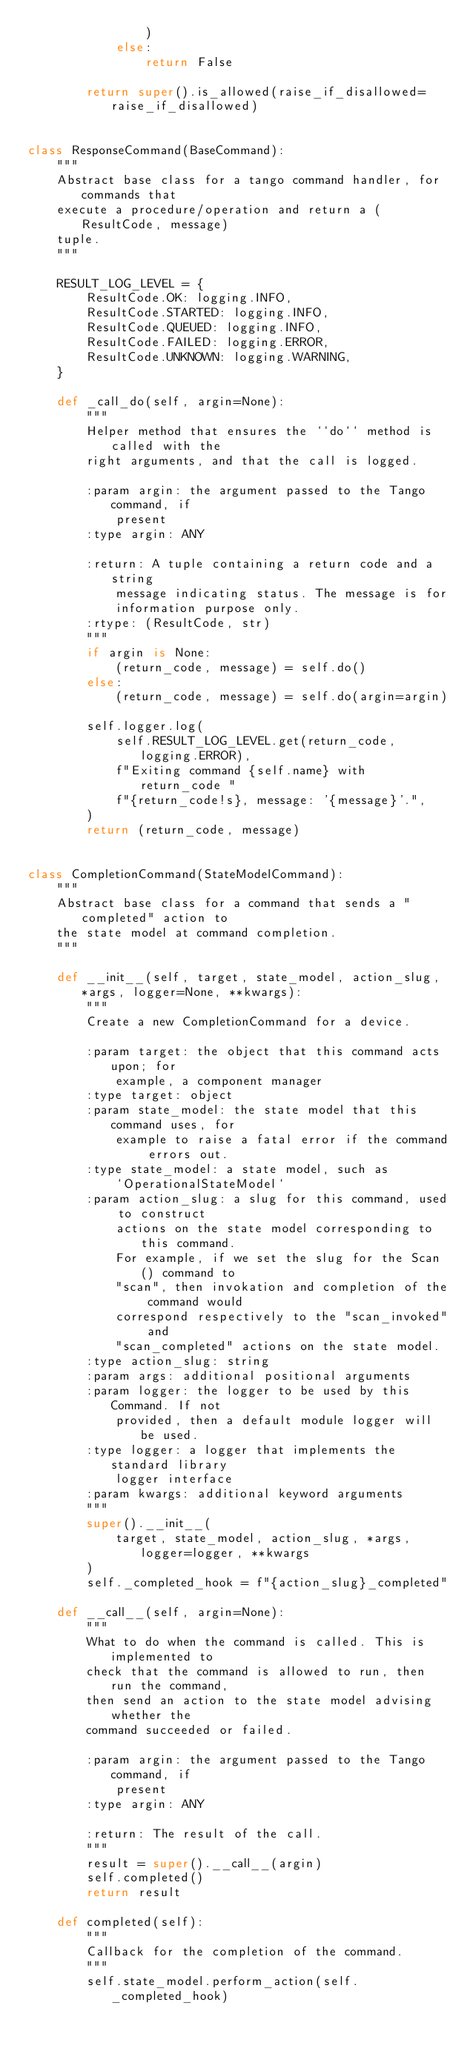<code> <loc_0><loc_0><loc_500><loc_500><_Python_>                )
            else:
                return False

        return super().is_allowed(raise_if_disallowed=raise_if_disallowed)


class ResponseCommand(BaseCommand):
    """
    Abstract base class for a tango command handler, for commands that
    execute a procedure/operation and return a (ResultCode, message)
    tuple.
    """

    RESULT_LOG_LEVEL = {
        ResultCode.OK: logging.INFO,
        ResultCode.STARTED: logging.INFO,
        ResultCode.QUEUED: logging.INFO,
        ResultCode.FAILED: logging.ERROR,
        ResultCode.UNKNOWN: logging.WARNING,
    }

    def _call_do(self, argin=None):
        """
        Helper method that ensures the ``do`` method is called with the
        right arguments, and that the call is logged.

        :param argin: the argument passed to the Tango command, if
            present
        :type argin: ANY

        :return: A tuple containing a return code and a string
            message indicating status. The message is for
            information purpose only.
        :rtype: (ResultCode, str)
        """
        if argin is None:
            (return_code, message) = self.do()
        else:
            (return_code, message) = self.do(argin=argin)

        self.logger.log(
            self.RESULT_LOG_LEVEL.get(return_code, logging.ERROR),
            f"Exiting command {self.name} with return_code "
            f"{return_code!s}, message: '{message}'.",
        )
        return (return_code, message)


class CompletionCommand(StateModelCommand):
    """
    Abstract base class for a command that sends a "completed" action to
    the state model at command completion.
    """

    def __init__(self, target, state_model, action_slug, *args, logger=None, **kwargs):
        """
        Create a new CompletionCommand for a device.

        :param target: the object that this command acts upon; for
            example, a component manager
        :type target: object
        :param state_model: the state model that this command uses, for
            example to raise a fatal error if the command errors out.
        :type state_model: a state model, such as
            `OperationalStateModel`
        :param action_slug: a slug for this command, used to construct
            actions on the state model corresponding to this command.
            For example, if we set the slug for the Scan() command to
            "scan", then invokation and completion of the command would
            correspond respectively to the "scan_invoked" and
            "scan_completed" actions on the state model.
        :type action_slug: string
        :param args: additional positional arguments
        :param logger: the logger to be used by this Command. If not
            provided, then a default module logger will be used.
        :type logger: a logger that implements the standard library
            logger interface
        :param kwargs: additional keyword arguments
        """
        super().__init__(
            target, state_model, action_slug, *args, logger=logger, **kwargs
        )
        self._completed_hook = f"{action_slug}_completed"

    def __call__(self, argin=None):
        """
        What to do when the command is called. This is implemented to
        check that the command is allowed to run, then run the command,
        then send an action to the state model advising whether the
        command succeeded or failed.

        :param argin: the argument passed to the Tango command, if
            present
        :type argin: ANY

        :return: The result of the call.
        """
        result = super().__call__(argin)
        self.completed()
        return result

    def completed(self):
        """
        Callback for the completion of the command.
        """
        self.state_model.perform_action(self._completed_hook)
</code> 